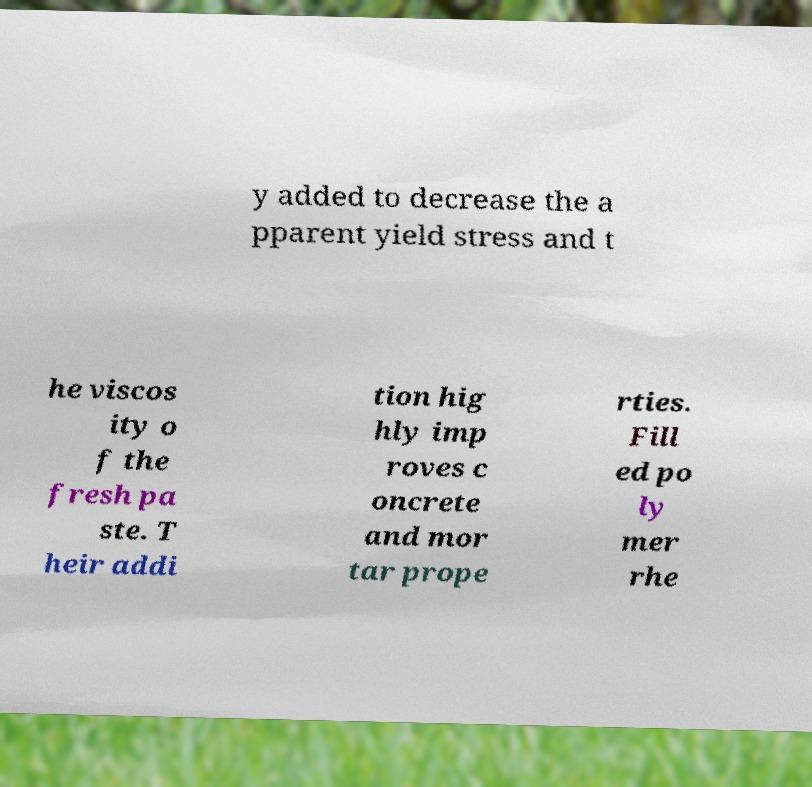Can you read and provide the text displayed in the image?This photo seems to have some interesting text. Can you extract and type it out for me? y added to decrease the a pparent yield stress and t he viscos ity o f the fresh pa ste. T heir addi tion hig hly imp roves c oncrete and mor tar prope rties. Fill ed po ly mer rhe 